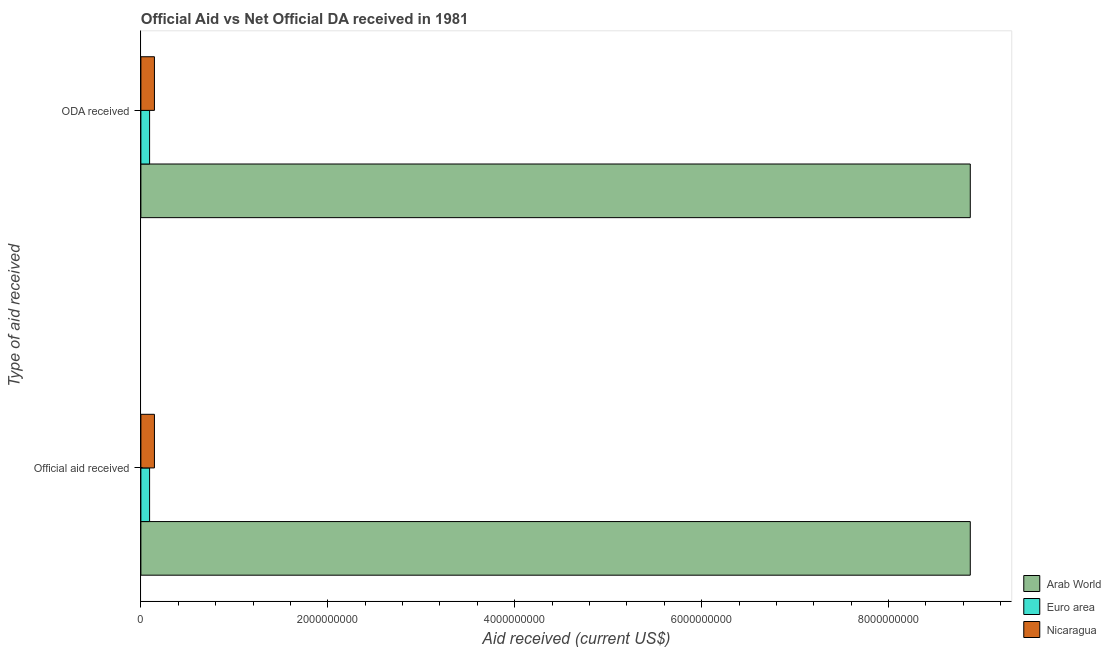How many groups of bars are there?
Keep it short and to the point. 2. How many bars are there on the 2nd tick from the top?
Give a very brief answer. 3. What is the label of the 1st group of bars from the top?
Ensure brevity in your answer.  ODA received. What is the official aid received in Euro area?
Make the answer very short. 9.32e+07. Across all countries, what is the maximum official aid received?
Offer a very short reply. 8.87e+09. Across all countries, what is the minimum oda received?
Your response must be concise. 9.32e+07. In which country was the oda received maximum?
Offer a very short reply. Arab World. In which country was the official aid received minimum?
Offer a very short reply. Euro area. What is the total official aid received in the graph?
Make the answer very short. 9.11e+09. What is the difference between the oda received in Nicaragua and that in Euro area?
Give a very brief answer. 5.18e+07. What is the difference between the official aid received in Euro area and the oda received in Nicaragua?
Provide a short and direct response. -5.18e+07. What is the average official aid received per country?
Provide a short and direct response. 3.04e+09. What is the ratio of the oda received in Nicaragua to that in Arab World?
Ensure brevity in your answer.  0.02. Is the oda received in Nicaragua less than that in Arab World?
Provide a succinct answer. Yes. What does the 2nd bar from the top in ODA received represents?
Offer a very short reply. Euro area. What does the 1st bar from the bottom in ODA received represents?
Keep it short and to the point. Arab World. Where does the legend appear in the graph?
Provide a succinct answer. Bottom right. How many legend labels are there?
Your answer should be compact. 3. What is the title of the graph?
Provide a succinct answer. Official Aid vs Net Official DA received in 1981 . Does "Uruguay" appear as one of the legend labels in the graph?
Give a very brief answer. No. What is the label or title of the X-axis?
Provide a short and direct response. Aid received (current US$). What is the label or title of the Y-axis?
Your answer should be compact. Type of aid received. What is the Aid received (current US$) in Arab World in Official aid received?
Provide a succinct answer. 8.87e+09. What is the Aid received (current US$) of Euro area in Official aid received?
Your answer should be compact. 9.32e+07. What is the Aid received (current US$) of Nicaragua in Official aid received?
Offer a very short reply. 1.45e+08. What is the Aid received (current US$) in Arab World in ODA received?
Your answer should be very brief. 8.87e+09. What is the Aid received (current US$) in Euro area in ODA received?
Your response must be concise. 9.32e+07. What is the Aid received (current US$) of Nicaragua in ODA received?
Keep it short and to the point. 1.45e+08. Across all Type of aid received, what is the maximum Aid received (current US$) of Arab World?
Make the answer very short. 8.87e+09. Across all Type of aid received, what is the maximum Aid received (current US$) of Euro area?
Ensure brevity in your answer.  9.32e+07. Across all Type of aid received, what is the maximum Aid received (current US$) of Nicaragua?
Your response must be concise. 1.45e+08. Across all Type of aid received, what is the minimum Aid received (current US$) of Arab World?
Offer a terse response. 8.87e+09. Across all Type of aid received, what is the minimum Aid received (current US$) of Euro area?
Give a very brief answer. 9.32e+07. Across all Type of aid received, what is the minimum Aid received (current US$) of Nicaragua?
Give a very brief answer. 1.45e+08. What is the total Aid received (current US$) of Arab World in the graph?
Offer a very short reply. 1.77e+1. What is the total Aid received (current US$) in Euro area in the graph?
Provide a succinct answer. 1.86e+08. What is the total Aid received (current US$) in Nicaragua in the graph?
Provide a succinct answer. 2.90e+08. What is the difference between the Aid received (current US$) in Nicaragua in Official aid received and that in ODA received?
Provide a short and direct response. 0. What is the difference between the Aid received (current US$) in Arab World in Official aid received and the Aid received (current US$) in Euro area in ODA received?
Your answer should be very brief. 8.78e+09. What is the difference between the Aid received (current US$) of Arab World in Official aid received and the Aid received (current US$) of Nicaragua in ODA received?
Give a very brief answer. 8.73e+09. What is the difference between the Aid received (current US$) of Euro area in Official aid received and the Aid received (current US$) of Nicaragua in ODA received?
Provide a short and direct response. -5.18e+07. What is the average Aid received (current US$) of Arab World per Type of aid received?
Provide a short and direct response. 8.87e+09. What is the average Aid received (current US$) of Euro area per Type of aid received?
Ensure brevity in your answer.  9.32e+07. What is the average Aid received (current US$) in Nicaragua per Type of aid received?
Offer a terse response. 1.45e+08. What is the difference between the Aid received (current US$) in Arab World and Aid received (current US$) in Euro area in Official aid received?
Offer a terse response. 8.78e+09. What is the difference between the Aid received (current US$) in Arab World and Aid received (current US$) in Nicaragua in Official aid received?
Offer a terse response. 8.73e+09. What is the difference between the Aid received (current US$) in Euro area and Aid received (current US$) in Nicaragua in Official aid received?
Your answer should be very brief. -5.18e+07. What is the difference between the Aid received (current US$) of Arab World and Aid received (current US$) of Euro area in ODA received?
Your response must be concise. 8.78e+09. What is the difference between the Aid received (current US$) in Arab World and Aid received (current US$) in Nicaragua in ODA received?
Your answer should be compact. 8.73e+09. What is the difference between the Aid received (current US$) of Euro area and Aid received (current US$) of Nicaragua in ODA received?
Make the answer very short. -5.18e+07. What is the ratio of the Aid received (current US$) of Nicaragua in Official aid received to that in ODA received?
Your answer should be compact. 1. What is the difference between the highest and the second highest Aid received (current US$) in Arab World?
Give a very brief answer. 0. What is the difference between the highest and the second highest Aid received (current US$) in Nicaragua?
Keep it short and to the point. 0. What is the difference between the highest and the lowest Aid received (current US$) of Euro area?
Provide a short and direct response. 0. 